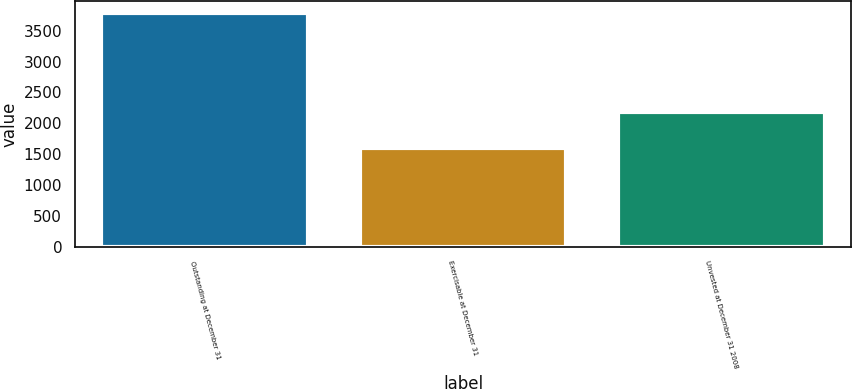Convert chart to OTSL. <chart><loc_0><loc_0><loc_500><loc_500><bar_chart><fcel>Outstanding at December 31<fcel>Exercisable at December 31<fcel>Unvested at December 31 2008<nl><fcel>3788<fcel>1600<fcel>2188<nl></chart> 